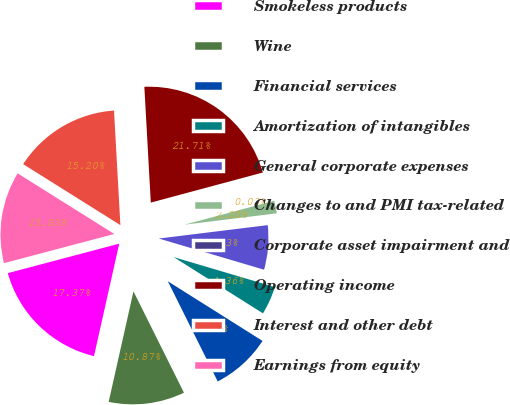Convert chart. <chart><loc_0><loc_0><loc_500><loc_500><pie_chart><fcel>Smokeless products<fcel>Wine<fcel>Financial services<fcel>Amortization of intangibles<fcel>General corporate expenses<fcel>Changes to and PMI tax-related<fcel>Corporate asset impairment and<fcel>Operating income<fcel>Interest and other debt<fcel>Earnings from equity<nl><fcel>17.37%<fcel>10.87%<fcel>8.7%<fcel>4.36%<fcel>6.53%<fcel>2.2%<fcel>0.03%<fcel>21.71%<fcel>15.2%<fcel>13.03%<nl></chart> 